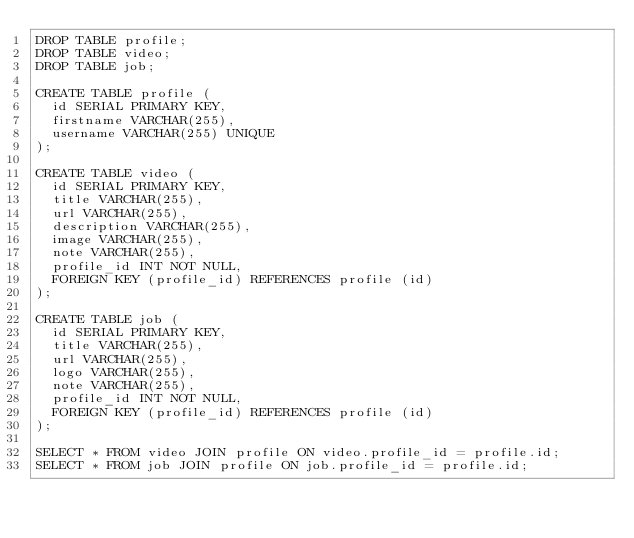<code> <loc_0><loc_0><loc_500><loc_500><_SQL_>DROP TABLE profile;
DROP TABLE video;
DROP TABLE job;

CREATE TABLE profile (
  id SERIAL PRIMARY KEY,
  firstname VARCHAR(255),
  username VARCHAR(255) UNIQUE
);

CREATE TABLE video (
  id SERIAL PRIMARY KEY,
  title VARCHAR(255),
  url VARCHAR(255),
  description VARCHAR(255),
  image VARCHAR(255),
  note VARCHAR(255),
  profile_id INT NOT NULL,
  FOREIGN KEY (profile_id) REFERENCES profile (id)
);

CREATE TABLE job (
  id SERIAL PRIMARY KEY,
  title VARCHAR(255),
  url VARCHAR(255),
  logo VARCHAR(255),
  note VARCHAR(255),
  profile_id INT NOT NULL,
  FOREIGN KEY (profile_id) REFERENCES profile (id)
);

SELECT * FROM video JOIN profile ON video.profile_id = profile.id;
SELECT * FROM job JOIN profile ON job.profile_id = profile.id;</code> 